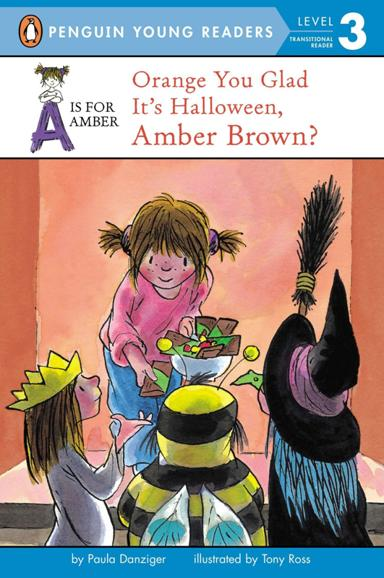What themes can be expected in the book based on the cover image? Based on the cover image, the book likely explores themes of friendship, Halloween festivities, and the spirit of sharing and celebration among children. These themes are depicted through the children's interactions and Halloween costumes. How might these themes be beneficial for young readers? These themes are beneficial as they teach young readers about the joys of friendship and sharing. Exploring Halloween through literature also helps children understand and engage with cultural festivities in a safe and educational context. 